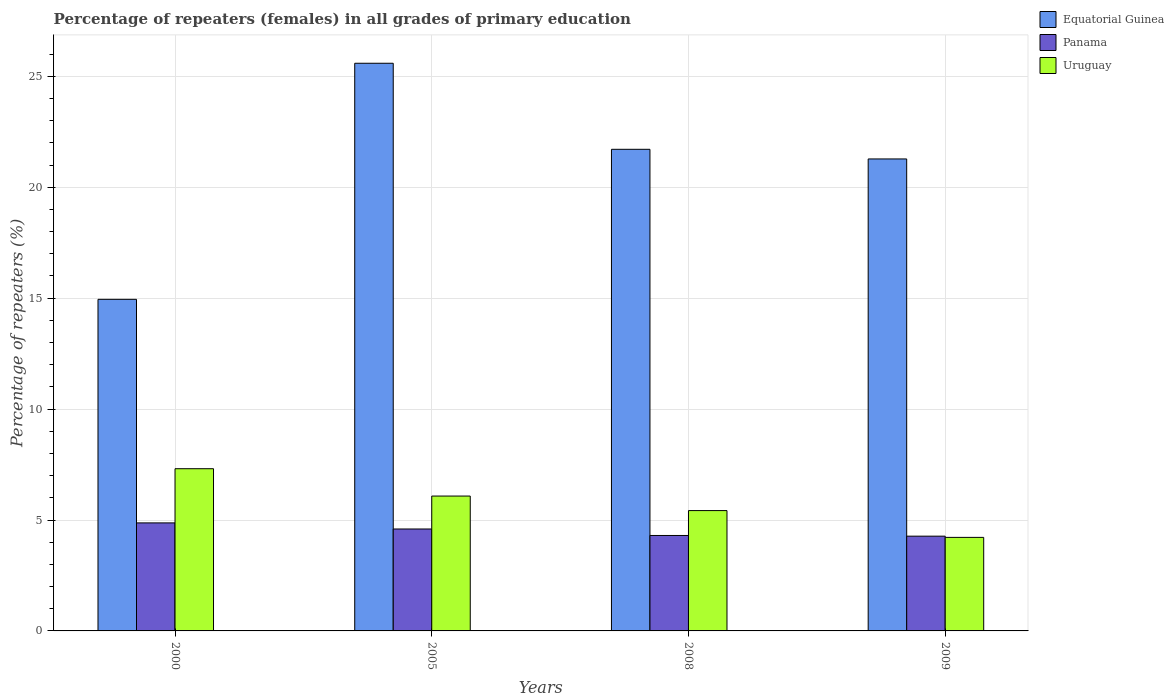How many different coloured bars are there?
Provide a succinct answer. 3. What is the percentage of repeaters (females) in Uruguay in 2005?
Provide a short and direct response. 6.08. Across all years, what is the maximum percentage of repeaters (females) in Equatorial Guinea?
Your answer should be compact. 25.59. Across all years, what is the minimum percentage of repeaters (females) in Uruguay?
Your response must be concise. 4.22. What is the total percentage of repeaters (females) in Equatorial Guinea in the graph?
Your answer should be very brief. 83.52. What is the difference between the percentage of repeaters (females) in Uruguay in 2000 and that in 2009?
Ensure brevity in your answer.  3.1. What is the difference between the percentage of repeaters (females) in Panama in 2008 and the percentage of repeaters (females) in Uruguay in 2009?
Give a very brief answer. 0.09. What is the average percentage of repeaters (females) in Uruguay per year?
Offer a terse response. 5.76. In the year 2008, what is the difference between the percentage of repeaters (females) in Panama and percentage of repeaters (females) in Uruguay?
Your answer should be compact. -1.12. In how many years, is the percentage of repeaters (females) in Panama greater than 7 %?
Provide a succinct answer. 0. What is the ratio of the percentage of repeaters (females) in Equatorial Guinea in 2008 to that in 2009?
Your answer should be very brief. 1.02. Is the percentage of repeaters (females) in Panama in 2000 less than that in 2009?
Your answer should be very brief. No. Is the difference between the percentage of repeaters (females) in Panama in 2005 and 2009 greater than the difference between the percentage of repeaters (females) in Uruguay in 2005 and 2009?
Your answer should be compact. No. What is the difference between the highest and the second highest percentage of repeaters (females) in Panama?
Your answer should be compact. 0.27. What is the difference between the highest and the lowest percentage of repeaters (females) in Equatorial Guinea?
Offer a terse response. 10.64. In how many years, is the percentage of repeaters (females) in Uruguay greater than the average percentage of repeaters (females) in Uruguay taken over all years?
Give a very brief answer. 2. Is the sum of the percentage of repeaters (females) in Uruguay in 2000 and 2005 greater than the maximum percentage of repeaters (females) in Panama across all years?
Offer a terse response. Yes. What does the 2nd bar from the left in 2005 represents?
Give a very brief answer. Panama. What does the 2nd bar from the right in 2000 represents?
Provide a short and direct response. Panama. How many bars are there?
Give a very brief answer. 12. How many years are there in the graph?
Your response must be concise. 4. What is the difference between two consecutive major ticks on the Y-axis?
Keep it short and to the point. 5. Does the graph contain any zero values?
Your response must be concise. No. Does the graph contain grids?
Offer a terse response. Yes. Where does the legend appear in the graph?
Your answer should be very brief. Top right. How are the legend labels stacked?
Your response must be concise. Vertical. What is the title of the graph?
Provide a short and direct response. Percentage of repeaters (females) in all grades of primary education. What is the label or title of the Y-axis?
Your answer should be compact. Percentage of repeaters (%). What is the Percentage of repeaters (%) of Equatorial Guinea in 2000?
Keep it short and to the point. 14.95. What is the Percentage of repeaters (%) of Panama in 2000?
Make the answer very short. 4.87. What is the Percentage of repeaters (%) of Uruguay in 2000?
Give a very brief answer. 7.31. What is the Percentage of repeaters (%) of Equatorial Guinea in 2005?
Your answer should be compact. 25.59. What is the Percentage of repeaters (%) of Panama in 2005?
Keep it short and to the point. 4.59. What is the Percentage of repeaters (%) of Uruguay in 2005?
Your answer should be very brief. 6.08. What is the Percentage of repeaters (%) in Equatorial Guinea in 2008?
Offer a very short reply. 21.71. What is the Percentage of repeaters (%) of Panama in 2008?
Make the answer very short. 4.3. What is the Percentage of repeaters (%) of Uruguay in 2008?
Your response must be concise. 5.42. What is the Percentage of repeaters (%) in Equatorial Guinea in 2009?
Your response must be concise. 21.28. What is the Percentage of repeaters (%) in Panama in 2009?
Keep it short and to the point. 4.27. What is the Percentage of repeaters (%) of Uruguay in 2009?
Your response must be concise. 4.22. Across all years, what is the maximum Percentage of repeaters (%) of Equatorial Guinea?
Provide a short and direct response. 25.59. Across all years, what is the maximum Percentage of repeaters (%) in Panama?
Provide a short and direct response. 4.87. Across all years, what is the maximum Percentage of repeaters (%) in Uruguay?
Your answer should be compact. 7.31. Across all years, what is the minimum Percentage of repeaters (%) of Equatorial Guinea?
Keep it short and to the point. 14.95. Across all years, what is the minimum Percentage of repeaters (%) in Panama?
Give a very brief answer. 4.27. Across all years, what is the minimum Percentage of repeaters (%) of Uruguay?
Ensure brevity in your answer.  4.22. What is the total Percentage of repeaters (%) of Equatorial Guinea in the graph?
Offer a very short reply. 83.52. What is the total Percentage of repeaters (%) in Panama in the graph?
Give a very brief answer. 18.04. What is the total Percentage of repeaters (%) of Uruguay in the graph?
Make the answer very short. 23.03. What is the difference between the Percentage of repeaters (%) in Equatorial Guinea in 2000 and that in 2005?
Your answer should be very brief. -10.64. What is the difference between the Percentage of repeaters (%) in Panama in 2000 and that in 2005?
Provide a succinct answer. 0.27. What is the difference between the Percentage of repeaters (%) of Uruguay in 2000 and that in 2005?
Make the answer very short. 1.23. What is the difference between the Percentage of repeaters (%) of Equatorial Guinea in 2000 and that in 2008?
Offer a terse response. -6.76. What is the difference between the Percentage of repeaters (%) of Panama in 2000 and that in 2008?
Keep it short and to the point. 0.57. What is the difference between the Percentage of repeaters (%) of Uruguay in 2000 and that in 2008?
Provide a short and direct response. 1.89. What is the difference between the Percentage of repeaters (%) in Equatorial Guinea in 2000 and that in 2009?
Ensure brevity in your answer.  -6.33. What is the difference between the Percentage of repeaters (%) of Panama in 2000 and that in 2009?
Provide a succinct answer. 0.6. What is the difference between the Percentage of repeaters (%) in Uruguay in 2000 and that in 2009?
Give a very brief answer. 3.1. What is the difference between the Percentage of repeaters (%) in Equatorial Guinea in 2005 and that in 2008?
Provide a succinct answer. 3.88. What is the difference between the Percentage of repeaters (%) of Panama in 2005 and that in 2008?
Offer a terse response. 0.29. What is the difference between the Percentage of repeaters (%) of Uruguay in 2005 and that in 2008?
Provide a succinct answer. 0.66. What is the difference between the Percentage of repeaters (%) of Equatorial Guinea in 2005 and that in 2009?
Your response must be concise. 4.31. What is the difference between the Percentage of repeaters (%) in Panama in 2005 and that in 2009?
Give a very brief answer. 0.32. What is the difference between the Percentage of repeaters (%) of Uruguay in 2005 and that in 2009?
Offer a very short reply. 1.86. What is the difference between the Percentage of repeaters (%) in Equatorial Guinea in 2008 and that in 2009?
Keep it short and to the point. 0.43. What is the difference between the Percentage of repeaters (%) of Panama in 2008 and that in 2009?
Ensure brevity in your answer.  0.03. What is the difference between the Percentage of repeaters (%) in Uruguay in 2008 and that in 2009?
Your answer should be very brief. 1.21. What is the difference between the Percentage of repeaters (%) of Equatorial Guinea in 2000 and the Percentage of repeaters (%) of Panama in 2005?
Keep it short and to the point. 10.35. What is the difference between the Percentage of repeaters (%) of Equatorial Guinea in 2000 and the Percentage of repeaters (%) of Uruguay in 2005?
Give a very brief answer. 8.87. What is the difference between the Percentage of repeaters (%) of Panama in 2000 and the Percentage of repeaters (%) of Uruguay in 2005?
Make the answer very short. -1.21. What is the difference between the Percentage of repeaters (%) in Equatorial Guinea in 2000 and the Percentage of repeaters (%) in Panama in 2008?
Make the answer very short. 10.64. What is the difference between the Percentage of repeaters (%) of Equatorial Guinea in 2000 and the Percentage of repeaters (%) of Uruguay in 2008?
Provide a succinct answer. 9.52. What is the difference between the Percentage of repeaters (%) of Panama in 2000 and the Percentage of repeaters (%) of Uruguay in 2008?
Make the answer very short. -0.55. What is the difference between the Percentage of repeaters (%) of Equatorial Guinea in 2000 and the Percentage of repeaters (%) of Panama in 2009?
Offer a very short reply. 10.68. What is the difference between the Percentage of repeaters (%) in Equatorial Guinea in 2000 and the Percentage of repeaters (%) in Uruguay in 2009?
Offer a very short reply. 10.73. What is the difference between the Percentage of repeaters (%) of Panama in 2000 and the Percentage of repeaters (%) of Uruguay in 2009?
Your answer should be very brief. 0.65. What is the difference between the Percentage of repeaters (%) of Equatorial Guinea in 2005 and the Percentage of repeaters (%) of Panama in 2008?
Make the answer very short. 21.29. What is the difference between the Percentage of repeaters (%) of Equatorial Guinea in 2005 and the Percentage of repeaters (%) of Uruguay in 2008?
Offer a terse response. 20.17. What is the difference between the Percentage of repeaters (%) of Panama in 2005 and the Percentage of repeaters (%) of Uruguay in 2008?
Your answer should be very brief. -0.83. What is the difference between the Percentage of repeaters (%) in Equatorial Guinea in 2005 and the Percentage of repeaters (%) in Panama in 2009?
Give a very brief answer. 21.32. What is the difference between the Percentage of repeaters (%) in Equatorial Guinea in 2005 and the Percentage of repeaters (%) in Uruguay in 2009?
Your response must be concise. 21.37. What is the difference between the Percentage of repeaters (%) of Panama in 2005 and the Percentage of repeaters (%) of Uruguay in 2009?
Your answer should be very brief. 0.38. What is the difference between the Percentage of repeaters (%) of Equatorial Guinea in 2008 and the Percentage of repeaters (%) of Panama in 2009?
Provide a succinct answer. 17.44. What is the difference between the Percentage of repeaters (%) in Equatorial Guinea in 2008 and the Percentage of repeaters (%) in Uruguay in 2009?
Provide a short and direct response. 17.49. What is the difference between the Percentage of repeaters (%) in Panama in 2008 and the Percentage of repeaters (%) in Uruguay in 2009?
Keep it short and to the point. 0.09. What is the average Percentage of repeaters (%) in Equatorial Guinea per year?
Your response must be concise. 20.88. What is the average Percentage of repeaters (%) of Panama per year?
Offer a very short reply. 4.51. What is the average Percentage of repeaters (%) of Uruguay per year?
Keep it short and to the point. 5.76. In the year 2000, what is the difference between the Percentage of repeaters (%) in Equatorial Guinea and Percentage of repeaters (%) in Panama?
Keep it short and to the point. 10.08. In the year 2000, what is the difference between the Percentage of repeaters (%) in Equatorial Guinea and Percentage of repeaters (%) in Uruguay?
Your answer should be compact. 7.64. In the year 2000, what is the difference between the Percentage of repeaters (%) of Panama and Percentage of repeaters (%) of Uruguay?
Your response must be concise. -2.44. In the year 2005, what is the difference between the Percentage of repeaters (%) of Equatorial Guinea and Percentage of repeaters (%) of Panama?
Your response must be concise. 20.99. In the year 2005, what is the difference between the Percentage of repeaters (%) in Equatorial Guinea and Percentage of repeaters (%) in Uruguay?
Make the answer very short. 19.51. In the year 2005, what is the difference between the Percentage of repeaters (%) of Panama and Percentage of repeaters (%) of Uruguay?
Offer a very short reply. -1.48. In the year 2008, what is the difference between the Percentage of repeaters (%) in Equatorial Guinea and Percentage of repeaters (%) in Panama?
Your response must be concise. 17.41. In the year 2008, what is the difference between the Percentage of repeaters (%) in Equatorial Guinea and Percentage of repeaters (%) in Uruguay?
Provide a short and direct response. 16.29. In the year 2008, what is the difference between the Percentage of repeaters (%) in Panama and Percentage of repeaters (%) in Uruguay?
Your answer should be very brief. -1.12. In the year 2009, what is the difference between the Percentage of repeaters (%) of Equatorial Guinea and Percentage of repeaters (%) of Panama?
Your answer should be very brief. 17. In the year 2009, what is the difference between the Percentage of repeaters (%) of Equatorial Guinea and Percentage of repeaters (%) of Uruguay?
Give a very brief answer. 17.06. In the year 2009, what is the difference between the Percentage of repeaters (%) of Panama and Percentage of repeaters (%) of Uruguay?
Provide a succinct answer. 0.05. What is the ratio of the Percentage of repeaters (%) in Equatorial Guinea in 2000 to that in 2005?
Provide a short and direct response. 0.58. What is the ratio of the Percentage of repeaters (%) of Panama in 2000 to that in 2005?
Give a very brief answer. 1.06. What is the ratio of the Percentage of repeaters (%) of Uruguay in 2000 to that in 2005?
Provide a short and direct response. 1.2. What is the ratio of the Percentage of repeaters (%) in Equatorial Guinea in 2000 to that in 2008?
Make the answer very short. 0.69. What is the ratio of the Percentage of repeaters (%) of Panama in 2000 to that in 2008?
Give a very brief answer. 1.13. What is the ratio of the Percentage of repeaters (%) in Uruguay in 2000 to that in 2008?
Offer a very short reply. 1.35. What is the ratio of the Percentage of repeaters (%) of Equatorial Guinea in 2000 to that in 2009?
Provide a short and direct response. 0.7. What is the ratio of the Percentage of repeaters (%) in Panama in 2000 to that in 2009?
Keep it short and to the point. 1.14. What is the ratio of the Percentage of repeaters (%) in Uruguay in 2000 to that in 2009?
Your answer should be compact. 1.73. What is the ratio of the Percentage of repeaters (%) of Equatorial Guinea in 2005 to that in 2008?
Ensure brevity in your answer.  1.18. What is the ratio of the Percentage of repeaters (%) of Panama in 2005 to that in 2008?
Ensure brevity in your answer.  1.07. What is the ratio of the Percentage of repeaters (%) of Uruguay in 2005 to that in 2008?
Your response must be concise. 1.12. What is the ratio of the Percentage of repeaters (%) of Equatorial Guinea in 2005 to that in 2009?
Your answer should be very brief. 1.2. What is the ratio of the Percentage of repeaters (%) in Panama in 2005 to that in 2009?
Your answer should be compact. 1.08. What is the ratio of the Percentage of repeaters (%) in Uruguay in 2005 to that in 2009?
Provide a short and direct response. 1.44. What is the ratio of the Percentage of repeaters (%) in Equatorial Guinea in 2008 to that in 2009?
Your answer should be very brief. 1.02. What is the ratio of the Percentage of repeaters (%) of Panama in 2008 to that in 2009?
Your answer should be very brief. 1.01. What is the ratio of the Percentage of repeaters (%) in Uruguay in 2008 to that in 2009?
Your answer should be compact. 1.29. What is the difference between the highest and the second highest Percentage of repeaters (%) in Equatorial Guinea?
Provide a succinct answer. 3.88. What is the difference between the highest and the second highest Percentage of repeaters (%) of Panama?
Keep it short and to the point. 0.27. What is the difference between the highest and the second highest Percentage of repeaters (%) of Uruguay?
Make the answer very short. 1.23. What is the difference between the highest and the lowest Percentage of repeaters (%) in Equatorial Guinea?
Ensure brevity in your answer.  10.64. What is the difference between the highest and the lowest Percentage of repeaters (%) in Panama?
Keep it short and to the point. 0.6. What is the difference between the highest and the lowest Percentage of repeaters (%) in Uruguay?
Provide a short and direct response. 3.1. 